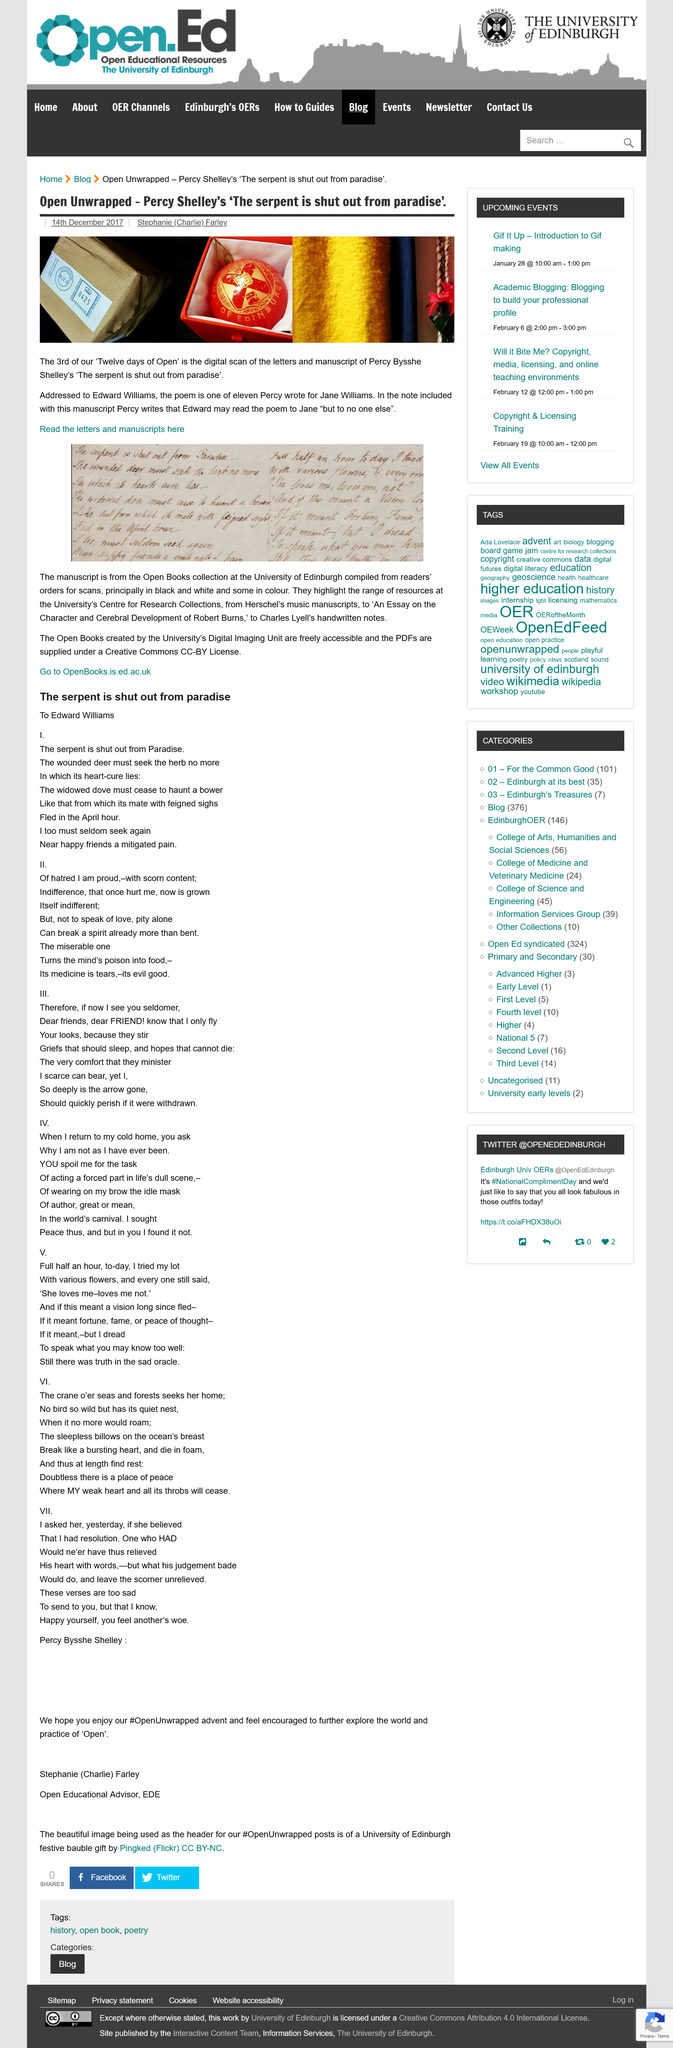Identify some key points in this picture. The digital scan, named "Twelve days of open," is a document that provides information about a specific topic. The poem in question is one of eleven in total. The letter is addressed to Edward Williams. 